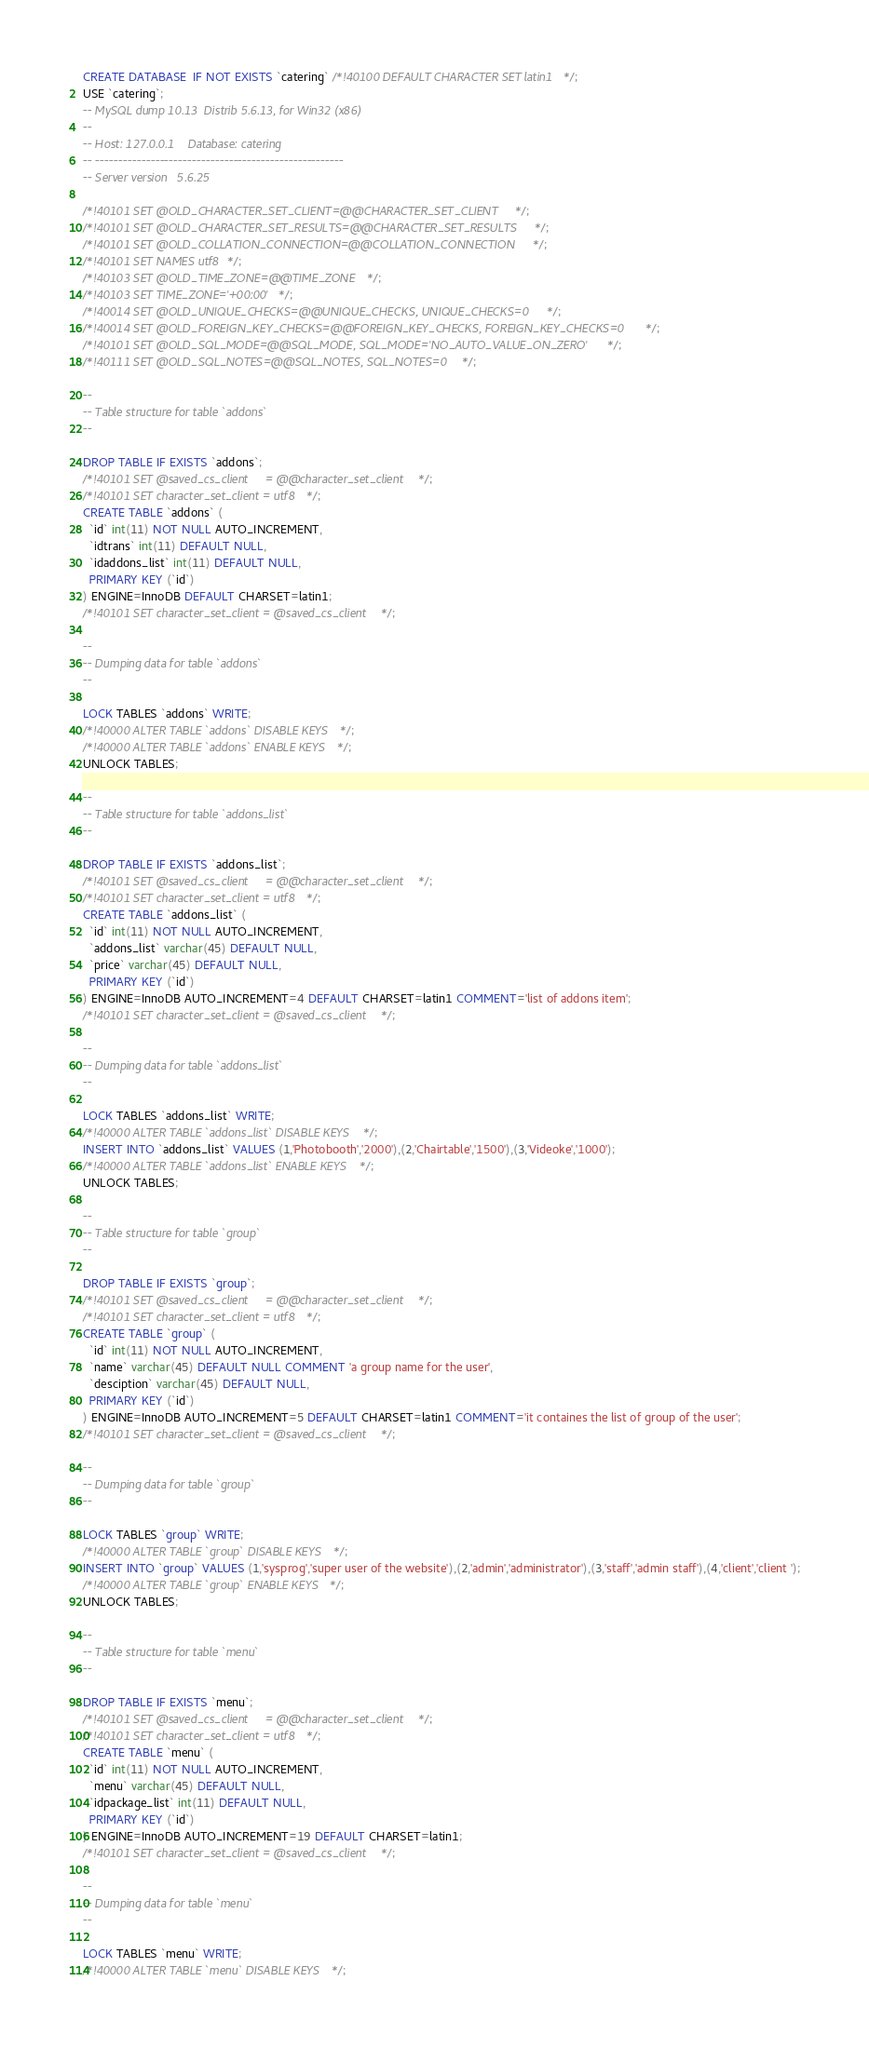<code> <loc_0><loc_0><loc_500><loc_500><_SQL_>CREATE DATABASE  IF NOT EXISTS `catering` /*!40100 DEFAULT CHARACTER SET latin1 */;
USE `catering`;
-- MySQL dump 10.13  Distrib 5.6.13, for Win32 (x86)
--
-- Host: 127.0.0.1    Database: catering
-- ------------------------------------------------------
-- Server version	5.6.25

/*!40101 SET @OLD_CHARACTER_SET_CLIENT=@@CHARACTER_SET_CLIENT */;
/*!40101 SET @OLD_CHARACTER_SET_RESULTS=@@CHARACTER_SET_RESULTS */;
/*!40101 SET @OLD_COLLATION_CONNECTION=@@COLLATION_CONNECTION */;
/*!40101 SET NAMES utf8 */;
/*!40103 SET @OLD_TIME_ZONE=@@TIME_ZONE */;
/*!40103 SET TIME_ZONE='+00:00' */;
/*!40014 SET @OLD_UNIQUE_CHECKS=@@UNIQUE_CHECKS, UNIQUE_CHECKS=0 */;
/*!40014 SET @OLD_FOREIGN_KEY_CHECKS=@@FOREIGN_KEY_CHECKS, FOREIGN_KEY_CHECKS=0 */;
/*!40101 SET @OLD_SQL_MODE=@@SQL_MODE, SQL_MODE='NO_AUTO_VALUE_ON_ZERO' */;
/*!40111 SET @OLD_SQL_NOTES=@@SQL_NOTES, SQL_NOTES=0 */;

--
-- Table structure for table `addons`
--

DROP TABLE IF EXISTS `addons`;
/*!40101 SET @saved_cs_client     = @@character_set_client */;
/*!40101 SET character_set_client = utf8 */;
CREATE TABLE `addons` (
  `id` int(11) NOT NULL AUTO_INCREMENT,
  `idtrans` int(11) DEFAULT NULL,
  `idaddons_list` int(11) DEFAULT NULL,
  PRIMARY KEY (`id`)
) ENGINE=InnoDB DEFAULT CHARSET=latin1;
/*!40101 SET character_set_client = @saved_cs_client */;

--
-- Dumping data for table `addons`
--

LOCK TABLES `addons` WRITE;
/*!40000 ALTER TABLE `addons` DISABLE KEYS */;
/*!40000 ALTER TABLE `addons` ENABLE KEYS */;
UNLOCK TABLES;

--
-- Table structure for table `addons_list`
--

DROP TABLE IF EXISTS `addons_list`;
/*!40101 SET @saved_cs_client     = @@character_set_client */;
/*!40101 SET character_set_client = utf8 */;
CREATE TABLE `addons_list` (
  `id` int(11) NOT NULL AUTO_INCREMENT,
  `addons_list` varchar(45) DEFAULT NULL,
  `price` varchar(45) DEFAULT NULL,
  PRIMARY KEY (`id`)
) ENGINE=InnoDB AUTO_INCREMENT=4 DEFAULT CHARSET=latin1 COMMENT='list of addons item';
/*!40101 SET character_set_client = @saved_cs_client */;

--
-- Dumping data for table `addons_list`
--

LOCK TABLES `addons_list` WRITE;
/*!40000 ALTER TABLE `addons_list` DISABLE KEYS */;
INSERT INTO `addons_list` VALUES (1,'Photobooth','2000'),(2,'Chairtable','1500'),(3,'Videoke','1000');
/*!40000 ALTER TABLE `addons_list` ENABLE KEYS */;
UNLOCK TABLES;

--
-- Table structure for table `group`
--

DROP TABLE IF EXISTS `group`;
/*!40101 SET @saved_cs_client     = @@character_set_client */;
/*!40101 SET character_set_client = utf8 */;
CREATE TABLE `group` (
  `id` int(11) NOT NULL AUTO_INCREMENT,
  `name` varchar(45) DEFAULT NULL COMMENT 'a group name for the user',
  `desciption` varchar(45) DEFAULT NULL,
  PRIMARY KEY (`id`)
) ENGINE=InnoDB AUTO_INCREMENT=5 DEFAULT CHARSET=latin1 COMMENT='it containes the list of group of the user';
/*!40101 SET character_set_client = @saved_cs_client */;

--
-- Dumping data for table `group`
--

LOCK TABLES `group` WRITE;
/*!40000 ALTER TABLE `group` DISABLE KEYS */;
INSERT INTO `group` VALUES (1,'sysprog','super user of the website'),(2,'admin','administrator'),(3,'staff','admin staff'),(4,'client','client ');
/*!40000 ALTER TABLE `group` ENABLE KEYS */;
UNLOCK TABLES;

--
-- Table structure for table `menu`
--

DROP TABLE IF EXISTS `menu`;
/*!40101 SET @saved_cs_client     = @@character_set_client */;
/*!40101 SET character_set_client = utf8 */;
CREATE TABLE `menu` (
  `id` int(11) NOT NULL AUTO_INCREMENT,
  `menu` varchar(45) DEFAULT NULL,
  `idpackage_list` int(11) DEFAULT NULL,
  PRIMARY KEY (`id`)
) ENGINE=InnoDB AUTO_INCREMENT=19 DEFAULT CHARSET=latin1;
/*!40101 SET character_set_client = @saved_cs_client */;

--
-- Dumping data for table `menu`
--

LOCK TABLES `menu` WRITE;
/*!40000 ALTER TABLE `menu` DISABLE KEYS */;</code> 